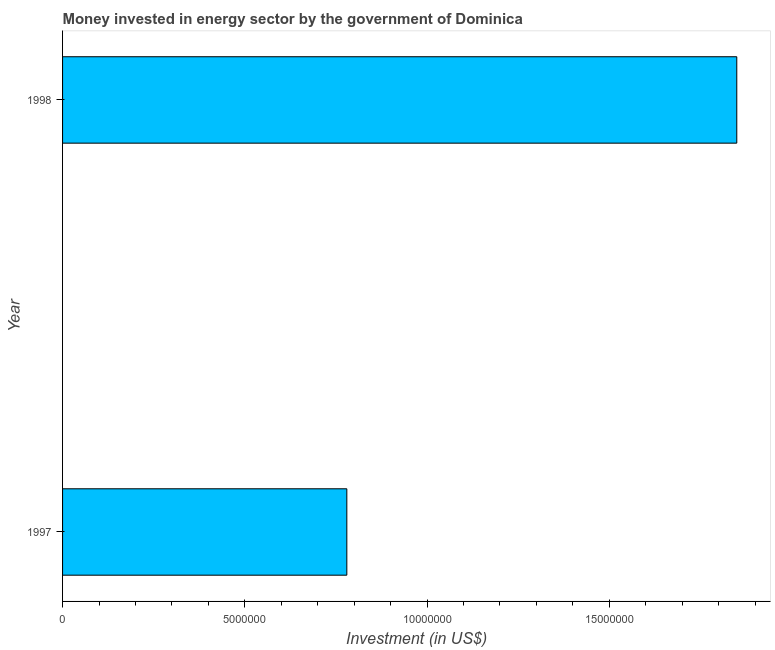Does the graph contain any zero values?
Ensure brevity in your answer.  No. Does the graph contain grids?
Ensure brevity in your answer.  No. What is the title of the graph?
Your answer should be compact. Money invested in energy sector by the government of Dominica. What is the label or title of the X-axis?
Give a very brief answer. Investment (in US$). What is the investment in energy in 1997?
Provide a succinct answer. 7.80e+06. Across all years, what is the maximum investment in energy?
Your answer should be very brief. 1.85e+07. Across all years, what is the minimum investment in energy?
Your response must be concise. 7.80e+06. What is the sum of the investment in energy?
Provide a succinct answer. 2.63e+07. What is the difference between the investment in energy in 1997 and 1998?
Your response must be concise. -1.07e+07. What is the average investment in energy per year?
Offer a terse response. 1.32e+07. What is the median investment in energy?
Keep it short and to the point. 1.32e+07. In how many years, is the investment in energy greater than 17000000 US$?
Offer a very short reply. 1. What is the ratio of the investment in energy in 1997 to that in 1998?
Offer a terse response. 0.42. Is the investment in energy in 1997 less than that in 1998?
Your answer should be very brief. Yes. In how many years, is the investment in energy greater than the average investment in energy taken over all years?
Your response must be concise. 1. What is the difference between two consecutive major ticks on the X-axis?
Your response must be concise. 5.00e+06. What is the Investment (in US$) of 1997?
Your answer should be compact. 7.80e+06. What is the Investment (in US$) of 1998?
Provide a short and direct response. 1.85e+07. What is the difference between the Investment (in US$) in 1997 and 1998?
Provide a short and direct response. -1.07e+07. What is the ratio of the Investment (in US$) in 1997 to that in 1998?
Keep it short and to the point. 0.42. 